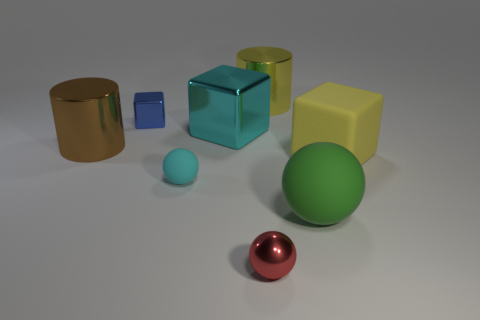Are any big gray metallic blocks visible?
Your answer should be compact. No. What number of objects are either things behind the cyan shiny object or big things that are on the right side of the brown shiny thing?
Offer a very short reply. 5. Does the tiny rubber object have the same color as the big metal cube?
Your answer should be compact. Yes. Is the number of big cyan metal balls less than the number of yellow rubber objects?
Your answer should be very brief. Yes. There is a tiny rubber thing; are there any big cyan metal things behind it?
Offer a very short reply. Yes. Does the tiny red thing have the same material as the green sphere?
Provide a short and direct response. No. The small shiny object that is the same shape as the large green thing is what color?
Keep it short and to the point. Red. Is the color of the big cube on the left side of the matte block the same as the small matte object?
Provide a succinct answer. Yes. What is the shape of the big shiny thing that is the same color as the matte block?
Keep it short and to the point. Cylinder. What number of yellow objects have the same material as the large yellow cylinder?
Your answer should be very brief. 0. 